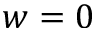Convert formula to latex. <formula><loc_0><loc_0><loc_500><loc_500>w = 0</formula> 